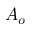<formula> <loc_0><loc_0><loc_500><loc_500>A _ { o }</formula> 